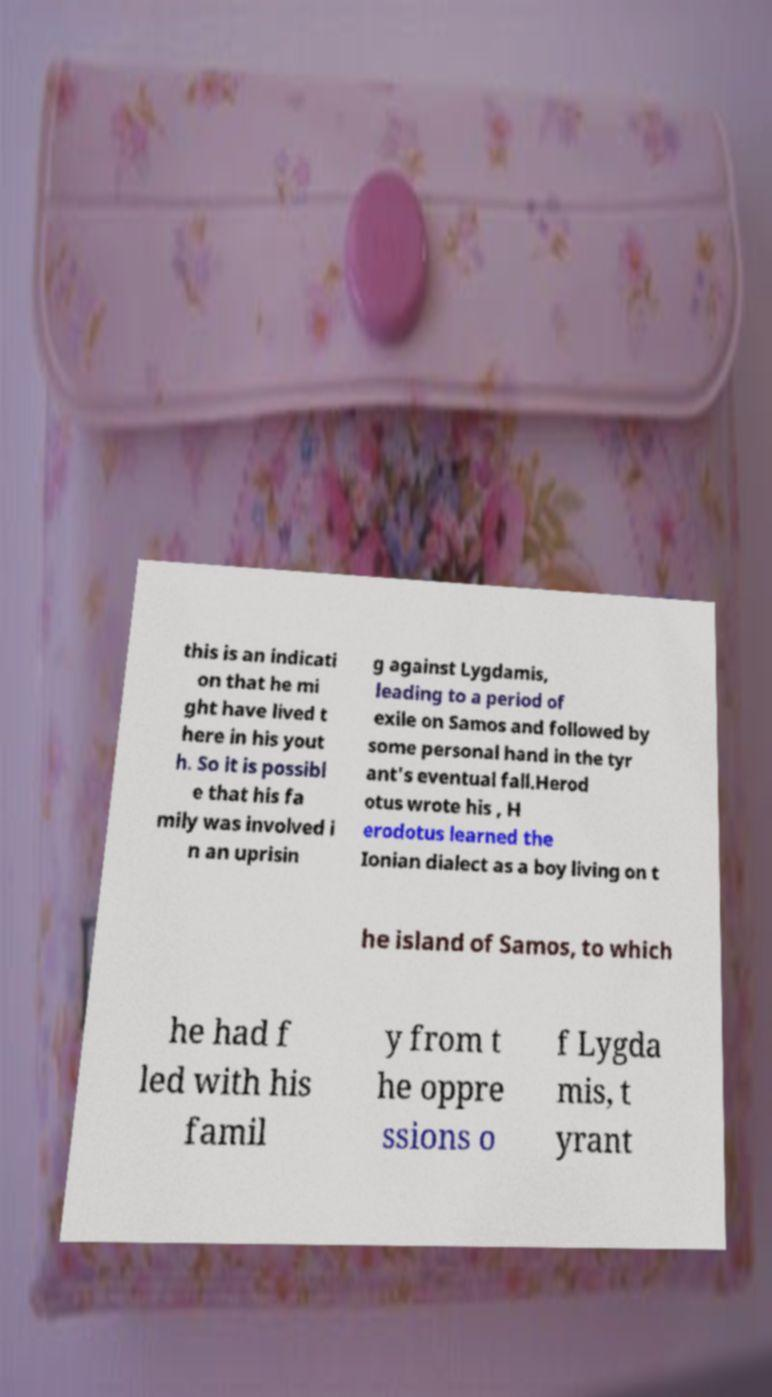Can you accurately transcribe the text from the provided image for me? this is an indicati on that he mi ght have lived t here in his yout h. So it is possibl e that his fa mily was involved i n an uprisin g against Lygdamis, leading to a period of exile on Samos and followed by some personal hand in the tyr ant's eventual fall.Herod otus wrote his , H erodotus learned the Ionian dialect as a boy living on t he island of Samos, to which he had f led with his famil y from t he oppre ssions o f Lygda mis, t yrant 